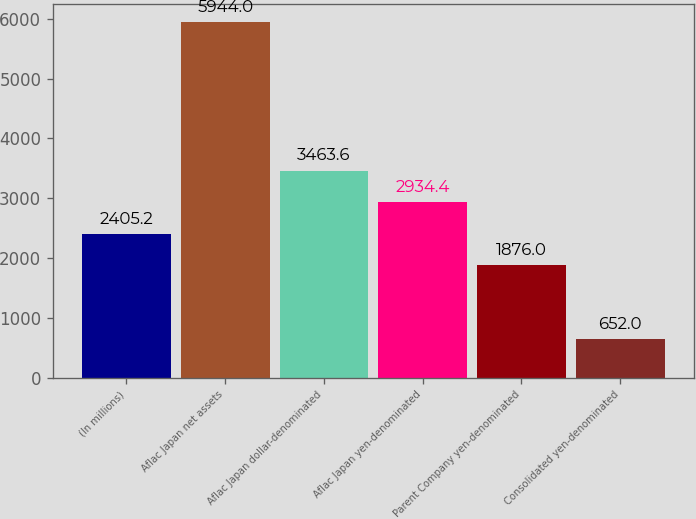Convert chart to OTSL. <chart><loc_0><loc_0><loc_500><loc_500><bar_chart><fcel>(In millions)<fcel>Aflac Japan net assets<fcel>Aflac Japan dollar-denominated<fcel>Aflac Japan yen-denominated<fcel>Parent Company yen-denominated<fcel>Consolidated yen-denominated<nl><fcel>2405.2<fcel>5944<fcel>3463.6<fcel>2934.4<fcel>1876<fcel>652<nl></chart> 